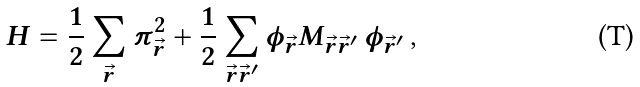<formula> <loc_0><loc_0><loc_500><loc_500>H = \frac { 1 } { 2 } \sum _ { \vec { r } } \pi _ { \vec { r } } ^ { 2 } + \frac { 1 } { 2 } \sum _ { \vec { r } \vec { r } ^ { \prime } } \phi _ { \vec { r } } M _ { \vec { r } \vec { r } ^ { \prime } } \, \phi _ { \vec { r } ^ { \prime } } \, ,</formula> 